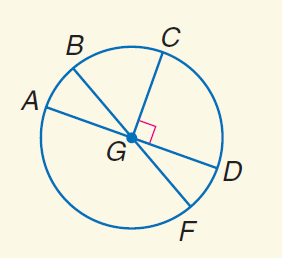Question: In \odot G, m \angle A G B = 30 and C G \perp G D. Find m \widehat A B.
Choices:
A. 30
B. 60
C. 90
D. 155
Answer with the letter. Answer: A Question: In \odot G, m \angle A G B = 30 and C G \perp G D. Find m \widehat B C D.
Choices:
A. 30
B. 45
C. 120
D. 150
Answer with the letter. Answer: D Question: In \odot G, m \angle A G B = 30 and C G \perp G D. Find m \widehat C D F.
Choices:
A. 30
B. 90
C. 120
D. 150
Answer with the letter. Answer: C Question: In \odot G, m \angle A G B = 30 and C G \perp G D. Find m \widehat F D.
Choices:
A. 30
B. 45
C. 90
D. 135
Answer with the letter. Answer: A Question: In \odot G, m \angle A G B = 30 and C G \perp G D. Find m \widehat B C.
Choices:
A. 30
B. 45
C. 60
D. 90
Answer with the letter. Answer: C 